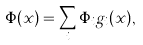Convert formula to latex. <formula><loc_0><loc_0><loc_500><loc_500>\Phi ( { x } ) = \sum _ { i } \Phi _ { i } g _ { i } ( { x } ) ,</formula> 